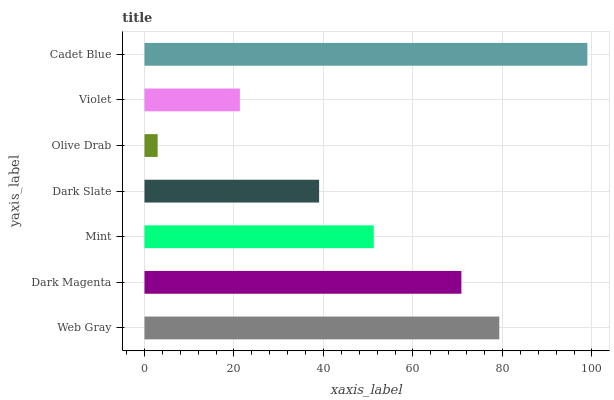Is Olive Drab the minimum?
Answer yes or no. Yes. Is Cadet Blue the maximum?
Answer yes or no. Yes. Is Dark Magenta the minimum?
Answer yes or no. No. Is Dark Magenta the maximum?
Answer yes or no. No. Is Web Gray greater than Dark Magenta?
Answer yes or no. Yes. Is Dark Magenta less than Web Gray?
Answer yes or no. Yes. Is Dark Magenta greater than Web Gray?
Answer yes or no. No. Is Web Gray less than Dark Magenta?
Answer yes or no. No. Is Mint the high median?
Answer yes or no. Yes. Is Mint the low median?
Answer yes or no. Yes. Is Cadet Blue the high median?
Answer yes or no. No. Is Cadet Blue the low median?
Answer yes or no. No. 